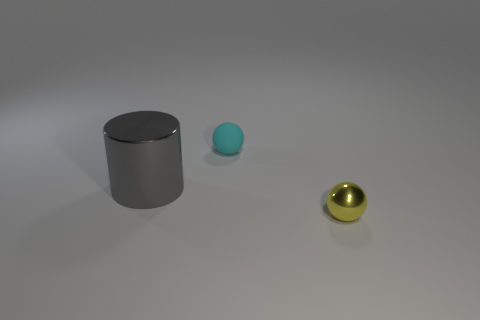Add 3 big cylinders. How many objects exist? 6 Subtract all spheres. How many objects are left? 1 Subtract all big cubes. Subtract all big gray metallic cylinders. How many objects are left? 2 Add 3 small yellow objects. How many small yellow objects are left? 4 Add 1 small red balls. How many small red balls exist? 1 Subtract 0 blue blocks. How many objects are left? 3 